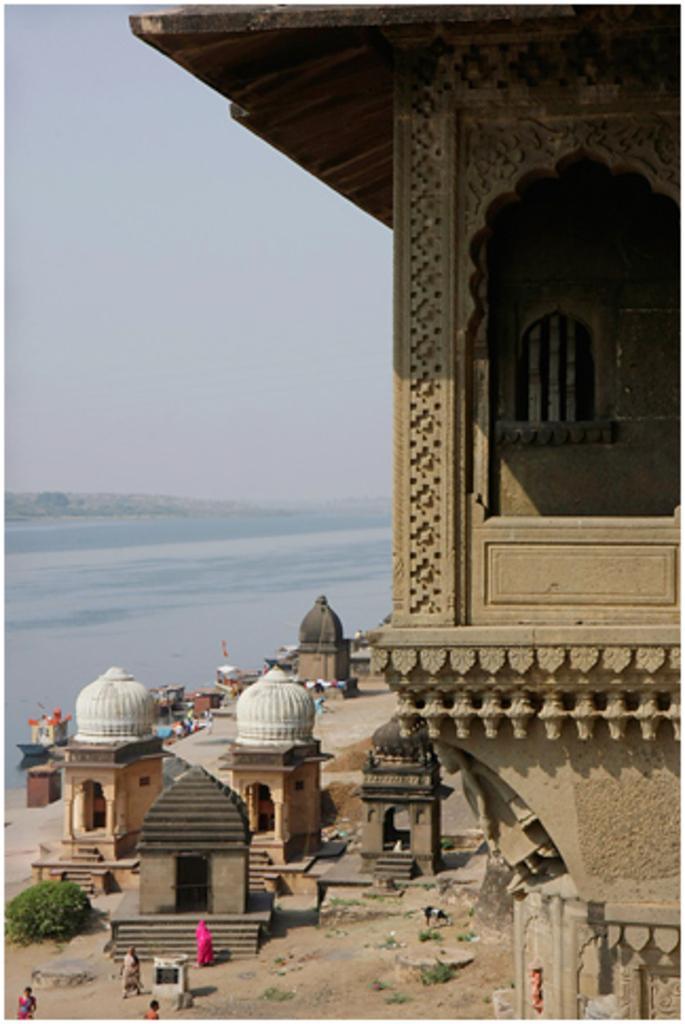Describe this image in one or two sentences. In the image we can see there are people standing on the ground. There are tombs and buildings. Behind there is an ocean and there is a clear sky. 